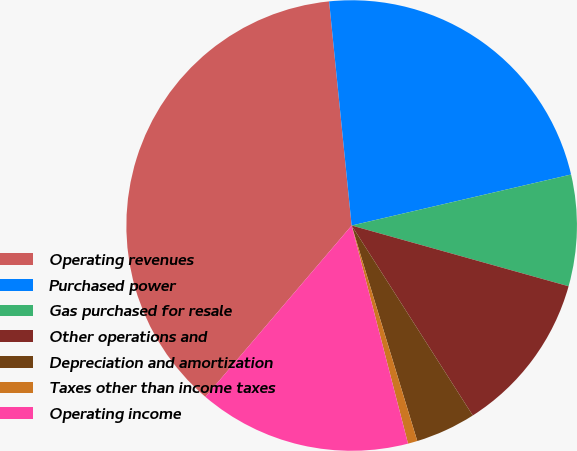<chart> <loc_0><loc_0><loc_500><loc_500><pie_chart><fcel>Operating revenues<fcel>Purchased power<fcel>Gas purchased for resale<fcel>Other operations and<fcel>Depreciation and amortization<fcel>Taxes other than income taxes<fcel>Operating income<nl><fcel>37.16%<fcel>22.96%<fcel>7.98%<fcel>11.62%<fcel>4.33%<fcel>0.68%<fcel>15.27%<nl></chart> 